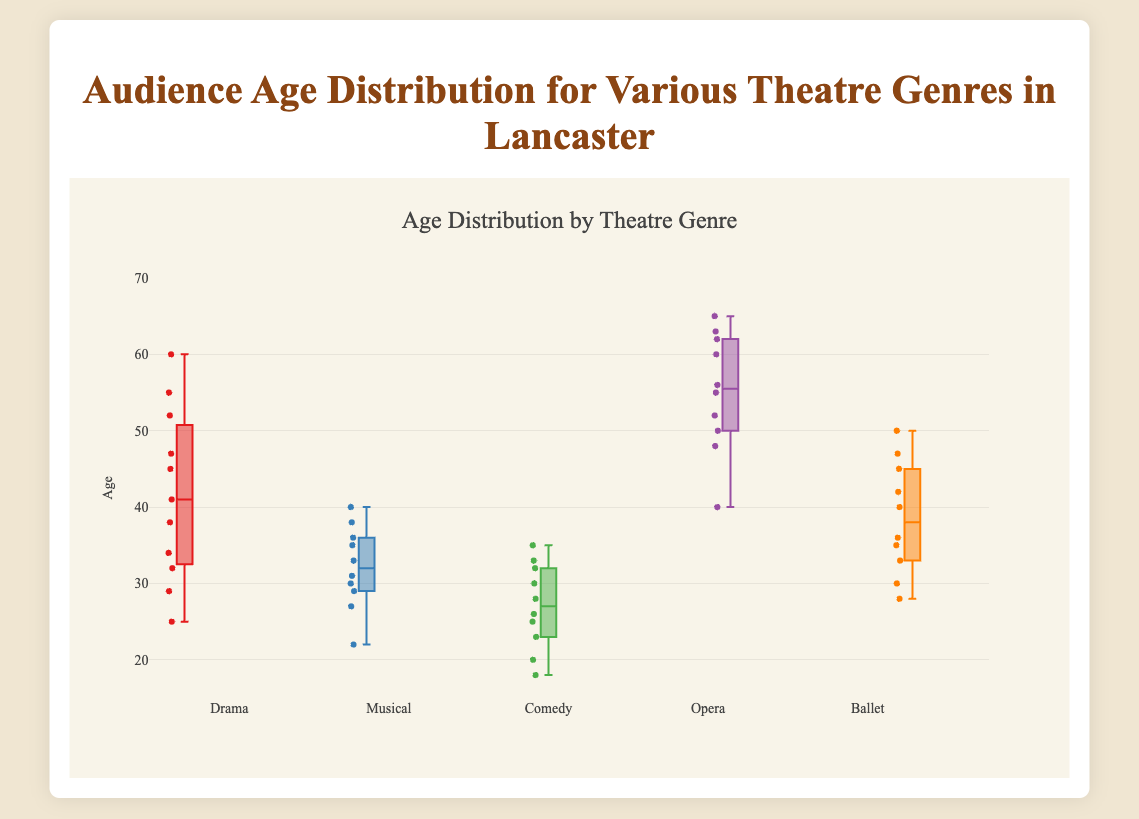What are the genres shown in the figure? The box plot illustrates the audience age distribution for five theatre genres: Drama, Musical, Comedy, Opera, and Ballet.
Answer: Drama, Musical, Comedy, Opera, Ballet What is the title of the figure? The figure's title is given at the top, emphasizing what the figure depicts about different theatre genres in Lancaster.
Answer: Audience Age Distribution for Various Theatre Genres in Lancaster Which genre has the most diverse age distribution? By looking at the spread of each box plot, the genre with the widest interquartile range (IQR) indicates the most diverse age distribution. Drama has the broadest IQR in the figure.
Answer: Drama Which genre has the youngest median audience age? The median is the line inside the box. By locating the lowest median value across all genres, it is clear that Comedy has the youngest median audience age.
Answer: Comedy What is the median age for audience members attending Opera? Locate the box plot for Opera and find the median line inside the box.
Answer: 56 years How does the median age of Ballet compare to Musical? Identify the median lines inside the boxes for Ballet and Musical, then compare. Ballet's median age is slightly higher than Musical's.
Answer: Ballet is higher What is the approximate age range for audiences of Musicals? Find the minimum and maximum points (whiskers) of the box plot for Musicals to determine its range.
Answer: 22 to 40 Which genre has the smallest interquartile range (IQR)? The IQR is the width of the box. The genre with the narrowest box plot is Comedy.
Answer: Comedy For which genre do the majority of audience members fall within the age range of 35 to 45? The majority of audience members are within the IQR (the box), so look for which genre's box plot falls primarily between 35 and 45. Opera and Ballet have boxes within this range.
Answer: Opera, Ballet 